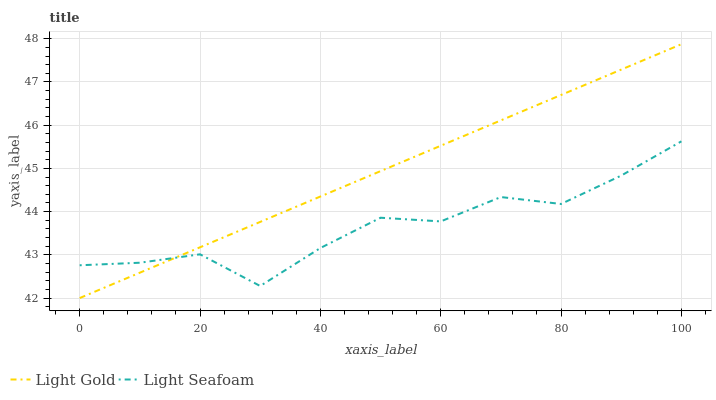Does Light Seafoam have the minimum area under the curve?
Answer yes or no. Yes. Does Light Gold have the maximum area under the curve?
Answer yes or no. Yes. Does Light Gold have the minimum area under the curve?
Answer yes or no. No. Is Light Gold the smoothest?
Answer yes or no. Yes. Is Light Seafoam the roughest?
Answer yes or no. Yes. Is Light Gold the roughest?
Answer yes or no. No. Does Light Gold have the lowest value?
Answer yes or no. Yes. Does Light Gold have the highest value?
Answer yes or no. Yes. Does Light Gold intersect Light Seafoam?
Answer yes or no. Yes. Is Light Gold less than Light Seafoam?
Answer yes or no. No. Is Light Gold greater than Light Seafoam?
Answer yes or no. No. 